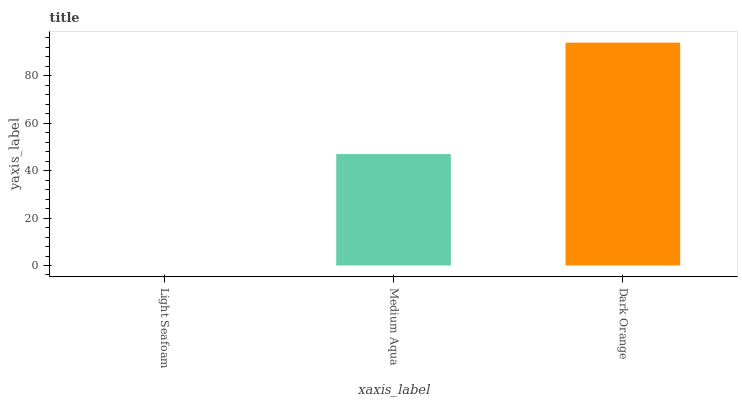Is Light Seafoam the minimum?
Answer yes or no. Yes. Is Dark Orange the maximum?
Answer yes or no. Yes. Is Medium Aqua the minimum?
Answer yes or no. No. Is Medium Aqua the maximum?
Answer yes or no. No. Is Medium Aqua greater than Light Seafoam?
Answer yes or no. Yes. Is Light Seafoam less than Medium Aqua?
Answer yes or no. Yes. Is Light Seafoam greater than Medium Aqua?
Answer yes or no. No. Is Medium Aqua less than Light Seafoam?
Answer yes or no. No. Is Medium Aqua the high median?
Answer yes or no. Yes. Is Medium Aqua the low median?
Answer yes or no. Yes. Is Dark Orange the high median?
Answer yes or no. No. Is Light Seafoam the low median?
Answer yes or no. No. 